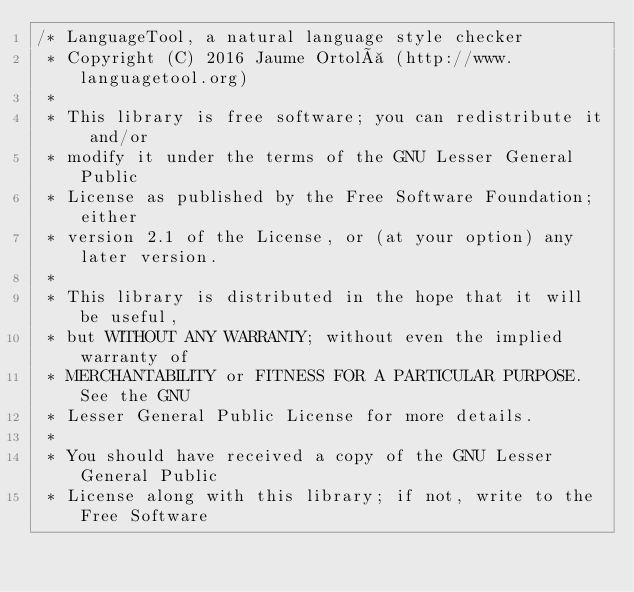<code> <loc_0><loc_0><loc_500><loc_500><_Java_>/* LanguageTool, a natural language style checker
 * Copyright (C) 2016 Jaume Ortolà (http://www.languagetool.org)
 *
 * This library is free software; you can redistribute it and/or
 * modify it under the terms of the GNU Lesser General Public
 * License as published by the Free Software Foundation; either
 * version 2.1 of the License, or (at your option) any later version.
 *
 * This library is distributed in the hope that it will be useful,
 * but WITHOUT ANY WARRANTY; without even the implied warranty of
 * MERCHANTABILITY or FITNESS FOR A PARTICULAR PURPOSE.  See the GNU
 * Lesser General Public License for more details.
 *
 * You should have received a copy of the GNU Lesser General Public
 * License along with this library; if not, write to the Free Software</code> 